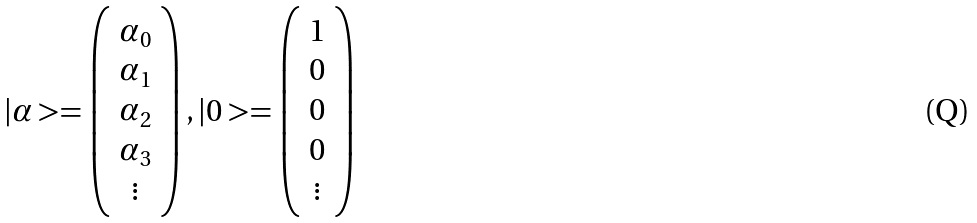<formula> <loc_0><loc_0><loc_500><loc_500>| \alpha > = \left ( \begin{array} { c } { { \alpha _ { 0 } } } \\ { { \alpha _ { 1 } } } \\ { { \alpha _ { 2 } } } \\ { { \alpha _ { 3 } } } \\ { \vdots } \end{array} \right ) , | 0 > = \left ( \begin{array} { c } { 1 } \\ { 0 } \\ { 0 } \\ { 0 } \\ { \vdots } \end{array} \right )</formula> 